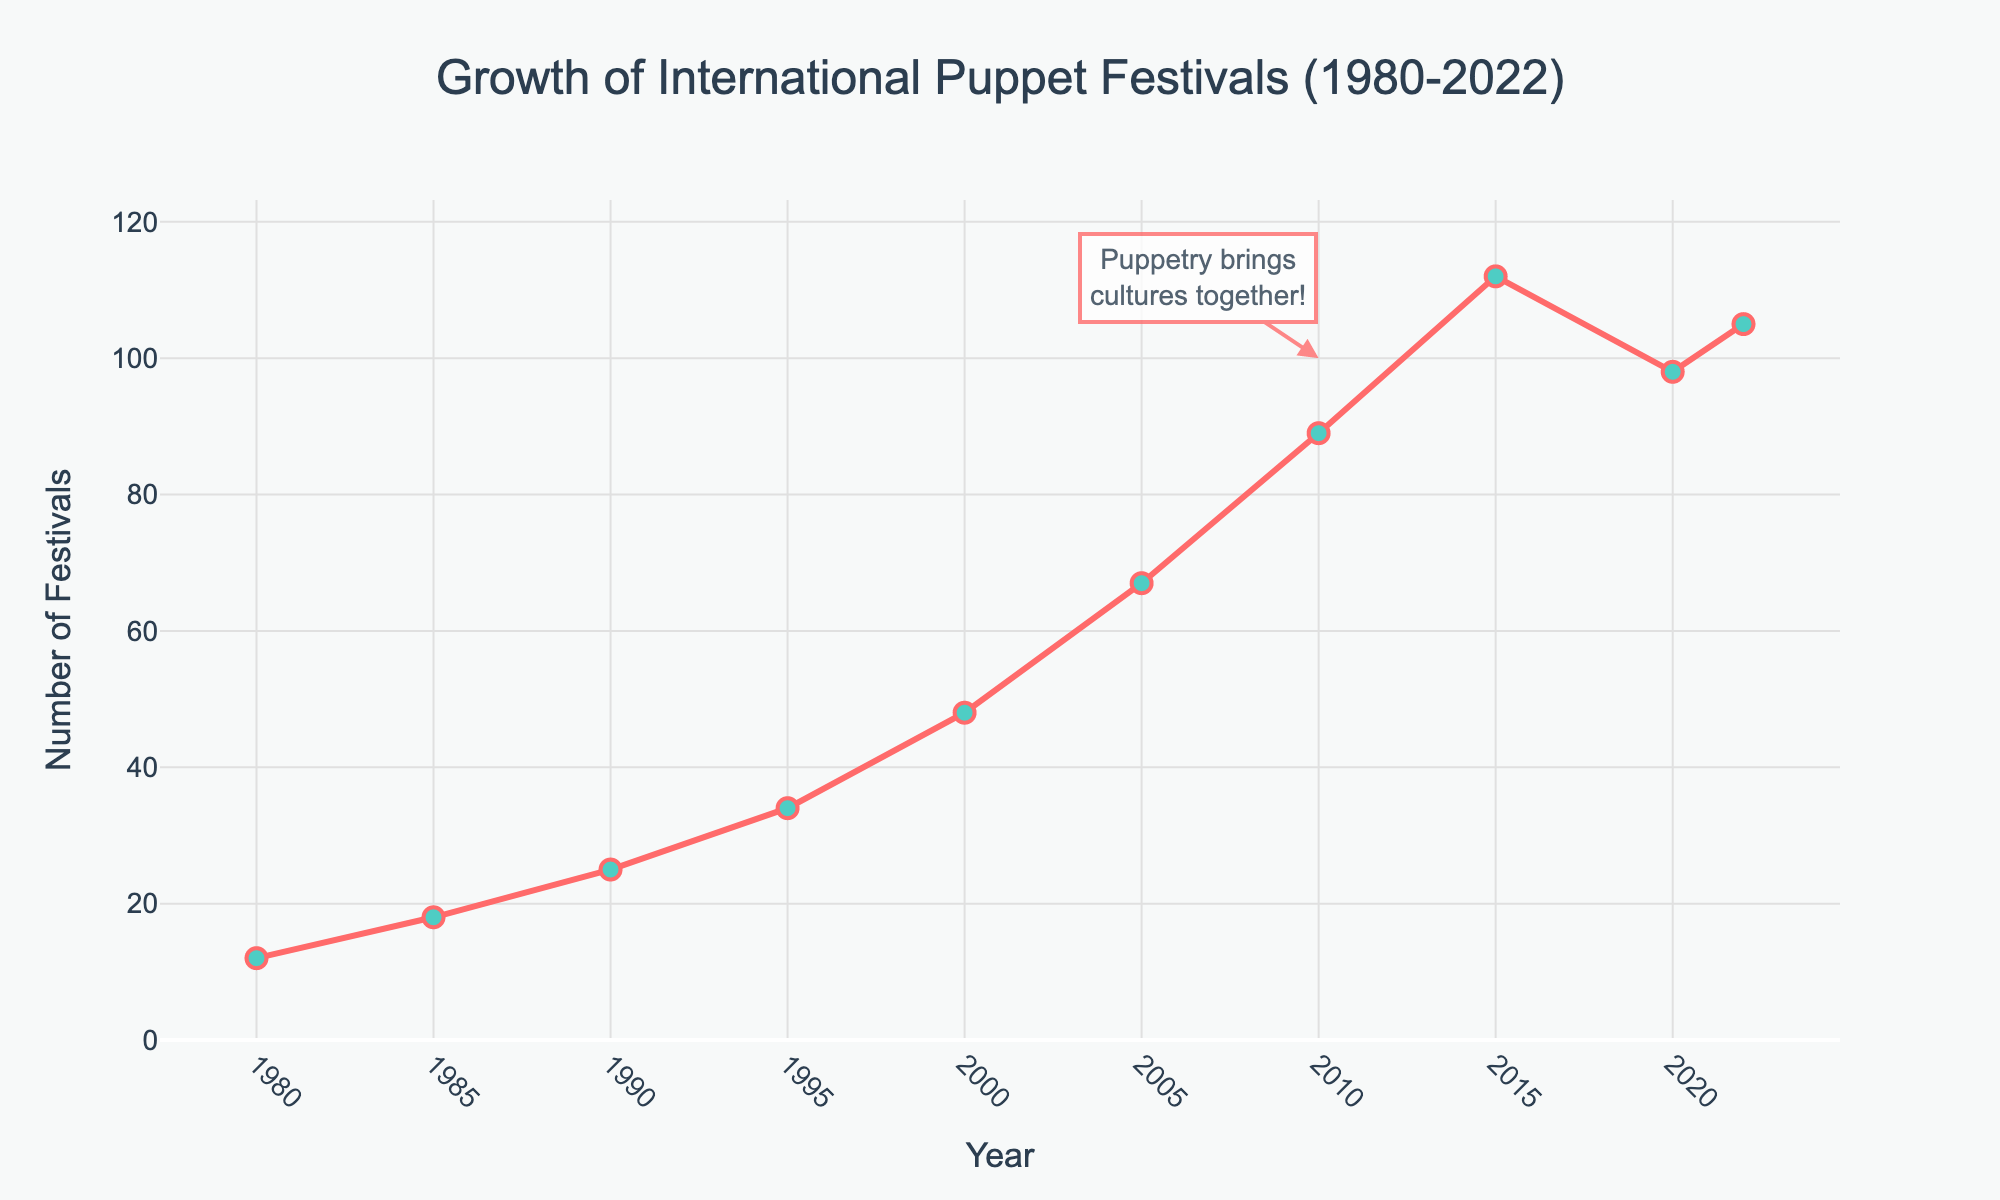What has been the general trend in the number of international puppet festivals from 1980 to 2022? The line chart shows a clear upward trend overall, with the number of international puppet festivals increasing over the years. Although there is a slight dip around 2020, the overall trend is positive.
Answer: Increasing trend Which period saw the highest increase in the number of international puppet festivals? By comparing the successive intervals, the period from 2005 to 2010 shows the highest increase, from 67 to 89 festivals, a rise of 22 festivals.
Answer: 2005-2010 How does the number of festivals in 2020 compare to that in 2010? The number of festivals in 2020 (98) is higher than in 2010 (89), despite a slight dip from the peak in 2015 (112).
Answer: More in 2020 What is the difference in the number of international puppet festivals between 1980 and 2022? Subtracting the number in 1980 (12) from the number in 2022 (105), the difference is 93.
Answer: 93 Between which consecutive pairs of years did the number of festivals remain constant or decrease? The number of festivals decreased between 2015 (112) and 2020 (98), and then rose slightly by 2022 (105).
Answer: 2015-2020 What is the average number of international puppet festivals from 1980 to 2022? The total sum of the festival numbers is 608 (12 + 18 + 25 + 34 + 48 + 67 + 89 + 112 + 98 + 105). There are 10 data points, so the average is 608/10 = 60.8.
Answer: 60.8 What does the annotation on the chart indicate about the cultural significance of puppetry? The annotation states "Puppetry brings cultures together!" and is positioned around the year 2010, emphasizing the cultural and unifying role of puppetry.
Answer: Cultural unity What is the color of the line representing the number of international puppet festivals, and what is its significance? The line is red, typically symbolizing passion and excitement, which can be associated with the enthusiasm and vibrancy of puppet festivals.
Answer: Red How did the number of festivals change from 2000 to 2005? The number of festivals rose from 48 in 2000 to 67 in 2005, marking an increase of 19 festivals.
Answer: Increased by 19 Is there any point where the number of festivals decreased between two consecutive years? Yes, the number of festivals decreased between 2015 (112) and 2020 (98).
Answer: Yes, 2015-2020 